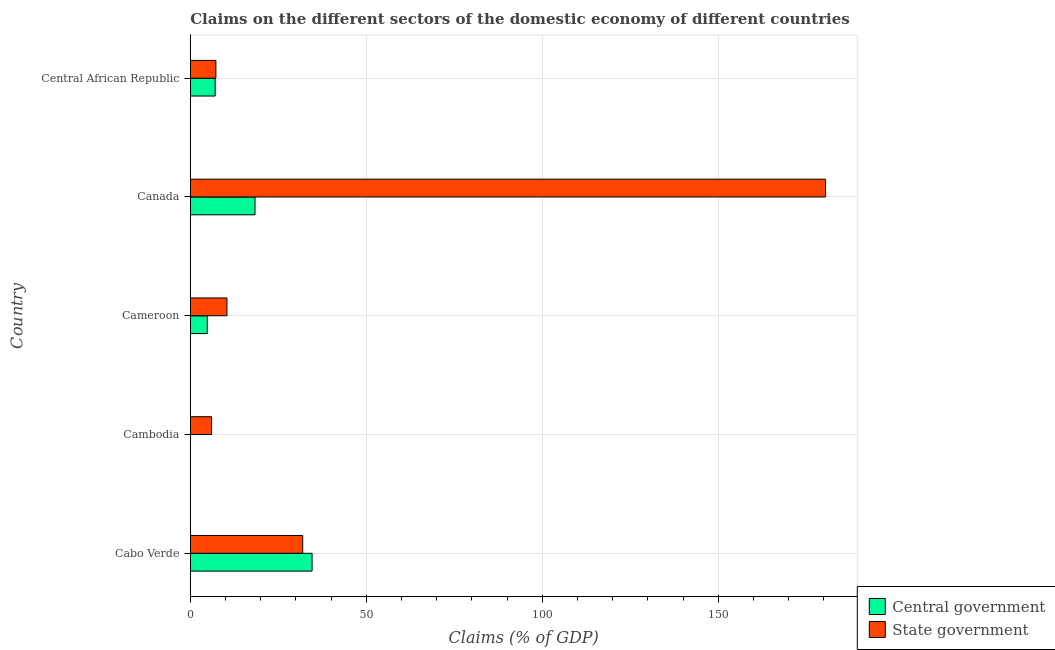Are the number of bars per tick equal to the number of legend labels?
Offer a very short reply. No. Are the number of bars on each tick of the Y-axis equal?
Give a very brief answer. No. How many bars are there on the 5th tick from the bottom?
Give a very brief answer. 2. What is the label of the 5th group of bars from the top?
Give a very brief answer. Cabo Verde. In how many cases, is the number of bars for a given country not equal to the number of legend labels?
Offer a terse response. 1. What is the claims on central government in Canada?
Make the answer very short. 18.39. Across all countries, what is the maximum claims on state government?
Ensure brevity in your answer.  180.49. What is the total claims on state government in the graph?
Make the answer very short. 236.15. What is the difference between the claims on central government in Cabo Verde and that in Central African Republic?
Provide a succinct answer. 27.54. What is the difference between the claims on state government in Cameroon and the claims on central government in Cambodia?
Offer a very short reply. 10.41. What is the average claims on central government per country?
Make the answer very short. 12.98. What is the difference between the claims on central government and claims on state government in Cabo Verde?
Keep it short and to the point. 2.66. In how many countries, is the claims on central government greater than 120 %?
Offer a very short reply. 0. What is the ratio of the claims on state government in Cameroon to that in Canada?
Offer a terse response. 0.06. Is the difference between the claims on central government in Cabo Verde and Cameroon greater than the difference between the claims on state government in Cabo Verde and Cameroon?
Provide a short and direct response. Yes. What is the difference between the highest and the second highest claims on central government?
Your response must be concise. 16.21. What is the difference between the highest and the lowest claims on central government?
Keep it short and to the point. 34.6. In how many countries, is the claims on state government greater than the average claims on state government taken over all countries?
Make the answer very short. 1. How many bars are there?
Your answer should be very brief. 9. Are the values on the major ticks of X-axis written in scientific E-notation?
Make the answer very short. No. Does the graph contain any zero values?
Your answer should be compact. Yes. How are the legend labels stacked?
Your answer should be very brief. Vertical. What is the title of the graph?
Your answer should be very brief. Claims on the different sectors of the domestic economy of different countries. Does "Electricity" appear as one of the legend labels in the graph?
Give a very brief answer. No. What is the label or title of the X-axis?
Your answer should be very brief. Claims (% of GDP). What is the label or title of the Y-axis?
Provide a short and direct response. Country. What is the Claims (% of GDP) of Central government in Cabo Verde?
Your response must be concise. 34.6. What is the Claims (% of GDP) in State government in Cabo Verde?
Make the answer very short. 31.94. What is the Claims (% of GDP) in Central government in Cambodia?
Your response must be concise. 0. What is the Claims (% of GDP) of State government in Cambodia?
Give a very brief answer. 6.04. What is the Claims (% of GDP) of Central government in Cameroon?
Your response must be concise. 4.83. What is the Claims (% of GDP) of State government in Cameroon?
Ensure brevity in your answer.  10.41. What is the Claims (% of GDP) of Central government in Canada?
Keep it short and to the point. 18.39. What is the Claims (% of GDP) of State government in Canada?
Provide a short and direct response. 180.49. What is the Claims (% of GDP) in Central government in Central African Republic?
Give a very brief answer. 7.06. What is the Claims (% of GDP) of State government in Central African Republic?
Make the answer very short. 7.27. Across all countries, what is the maximum Claims (% of GDP) in Central government?
Give a very brief answer. 34.6. Across all countries, what is the maximum Claims (% of GDP) of State government?
Keep it short and to the point. 180.49. Across all countries, what is the minimum Claims (% of GDP) of State government?
Make the answer very short. 6.04. What is the total Claims (% of GDP) of Central government in the graph?
Ensure brevity in your answer.  64.89. What is the total Claims (% of GDP) of State government in the graph?
Your answer should be compact. 236.15. What is the difference between the Claims (% of GDP) of State government in Cabo Verde and that in Cambodia?
Your answer should be compact. 25.91. What is the difference between the Claims (% of GDP) of Central government in Cabo Verde and that in Cameroon?
Offer a terse response. 29.77. What is the difference between the Claims (% of GDP) in State government in Cabo Verde and that in Cameroon?
Your answer should be very brief. 21.53. What is the difference between the Claims (% of GDP) in Central government in Cabo Verde and that in Canada?
Your answer should be compact. 16.21. What is the difference between the Claims (% of GDP) of State government in Cabo Verde and that in Canada?
Offer a very short reply. -148.54. What is the difference between the Claims (% of GDP) of Central government in Cabo Verde and that in Central African Republic?
Your answer should be compact. 27.54. What is the difference between the Claims (% of GDP) of State government in Cabo Verde and that in Central African Republic?
Make the answer very short. 24.67. What is the difference between the Claims (% of GDP) in State government in Cambodia and that in Cameroon?
Ensure brevity in your answer.  -4.38. What is the difference between the Claims (% of GDP) in State government in Cambodia and that in Canada?
Your answer should be compact. -174.45. What is the difference between the Claims (% of GDP) in State government in Cambodia and that in Central African Republic?
Your answer should be compact. -1.24. What is the difference between the Claims (% of GDP) in Central government in Cameroon and that in Canada?
Your answer should be compact. -13.56. What is the difference between the Claims (% of GDP) of State government in Cameroon and that in Canada?
Make the answer very short. -170.07. What is the difference between the Claims (% of GDP) of Central government in Cameroon and that in Central African Republic?
Make the answer very short. -2.22. What is the difference between the Claims (% of GDP) of State government in Cameroon and that in Central African Republic?
Offer a terse response. 3.14. What is the difference between the Claims (% of GDP) of Central government in Canada and that in Central African Republic?
Your response must be concise. 11.33. What is the difference between the Claims (% of GDP) in State government in Canada and that in Central African Republic?
Offer a very short reply. 173.21. What is the difference between the Claims (% of GDP) in Central government in Cabo Verde and the Claims (% of GDP) in State government in Cambodia?
Provide a succinct answer. 28.57. What is the difference between the Claims (% of GDP) of Central government in Cabo Verde and the Claims (% of GDP) of State government in Cameroon?
Keep it short and to the point. 24.19. What is the difference between the Claims (% of GDP) in Central government in Cabo Verde and the Claims (% of GDP) in State government in Canada?
Your answer should be very brief. -145.88. What is the difference between the Claims (% of GDP) in Central government in Cabo Verde and the Claims (% of GDP) in State government in Central African Republic?
Give a very brief answer. 27.33. What is the difference between the Claims (% of GDP) in Central government in Cameroon and the Claims (% of GDP) in State government in Canada?
Make the answer very short. -175.65. What is the difference between the Claims (% of GDP) in Central government in Cameroon and the Claims (% of GDP) in State government in Central African Republic?
Your answer should be compact. -2.44. What is the difference between the Claims (% of GDP) of Central government in Canada and the Claims (% of GDP) of State government in Central African Republic?
Keep it short and to the point. 11.12. What is the average Claims (% of GDP) in Central government per country?
Give a very brief answer. 12.98. What is the average Claims (% of GDP) in State government per country?
Your answer should be very brief. 47.23. What is the difference between the Claims (% of GDP) in Central government and Claims (% of GDP) in State government in Cabo Verde?
Your response must be concise. 2.66. What is the difference between the Claims (% of GDP) in Central government and Claims (% of GDP) in State government in Cameroon?
Your response must be concise. -5.58. What is the difference between the Claims (% of GDP) in Central government and Claims (% of GDP) in State government in Canada?
Ensure brevity in your answer.  -162.09. What is the difference between the Claims (% of GDP) of Central government and Claims (% of GDP) of State government in Central African Republic?
Make the answer very short. -0.22. What is the ratio of the Claims (% of GDP) in State government in Cabo Verde to that in Cambodia?
Your response must be concise. 5.29. What is the ratio of the Claims (% of GDP) of Central government in Cabo Verde to that in Cameroon?
Your answer should be compact. 7.16. What is the ratio of the Claims (% of GDP) in State government in Cabo Verde to that in Cameroon?
Your response must be concise. 3.07. What is the ratio of the Claims (% of GDP) of Central government in Cabo Verde to that in Canada?
Provide a succinct answer. 1.88. What is the ratio of the Claims (% of GDP) of State government in Cabo Verde to that in Canada?
Make the answer very short. 0.18. What is the ratio of the Claims (% of GDP) of Central government in Cabo Verde to that in Central African Republic?
Provide a succinct answer. 4.9. What is the ratio of the Claims (% of GDP) in State government in Cabo Verde to that in Central African Republic?
Give a very brief answer. 4.39. What is the ratio of the Claims (% of GDP) in State government in Cambodia to that in Cameroon?
Offer a very short reply. 0.58. What is the ratio of the Claims (% of GDP) in State government in Cambodia to that in Canada?
Your answer should be compact. 0.03. What is the ratio of the Claims (% of GDP) in State government in Cambodia to that in Central African Republic?
Offer a very short reply. 0.83. What is the ratio of the Claims (% of GDP) in Central government in Cameroon to that in Canada?
Give a very brief answer. 0.26. What is the ratio of the Claims (% of GDP) of State government in Cameroon to that in Canada?
Provide a short and direct response. 0.06. What is the ratio of the Claims (% of GDP) of Central government in Cameroon to that in Central African Republic?
Your answer should be very brief. 0.69. What is the ratio of the Claims (% of GDP) in State government in Cameroon to that in Central African Republic?
Offer a very short reply. 1.43. What is the ratio of the Claims (% of GDP) in Central government in Canada to that in Central African Republic?
Offer a very short reply. 2.61. What is the ratio of the Claims (% of GDP) in State government in Canada to that in Central African Republic?
Ensure brevity in your answer.  24.81. What is the difference between the highest and the second highest Claims (% of GDP) of Central government?
Your answer should be compact. 16.21. What is the difference between the highest and the second highest Claims (% of GDP) of State government?
Provide a short and direct response. 148.54. What is the difference between the highest and the lowest Claims (% of GDP) of Central government?
Provide a short and direct response. 34.6. What is the difference between the highest and the lowest Claims (% of GDP) of State government?
Keep it short and to the point. 174.45. 